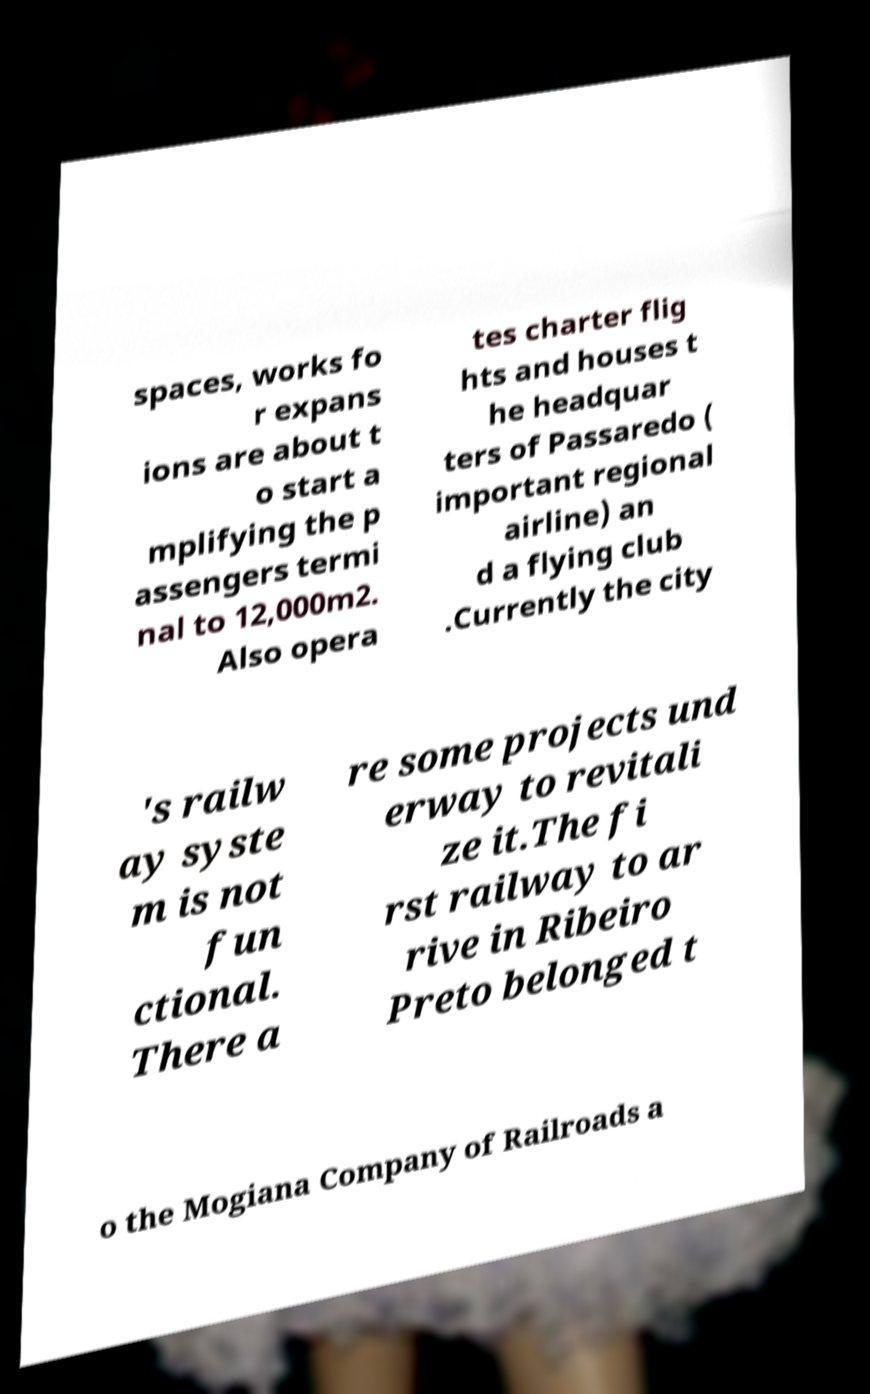I need the written content from this picture converted into text. Can you do that? spaces, works fo r expans ions are about t o start a mplifying the p assengers termi nal to 12,000m2. Also opera tes charter flig hts and houses t he headquar ters of Passaredo ( important regional airline) an d a flying club .Currently the city 's railw ay syste m is not fun ctional. There a re some projects und erway to revitali ze it.The fi rst railway to ar rive in Ribeiro Preto belonged t o the Mogiana Company of Railroads a 